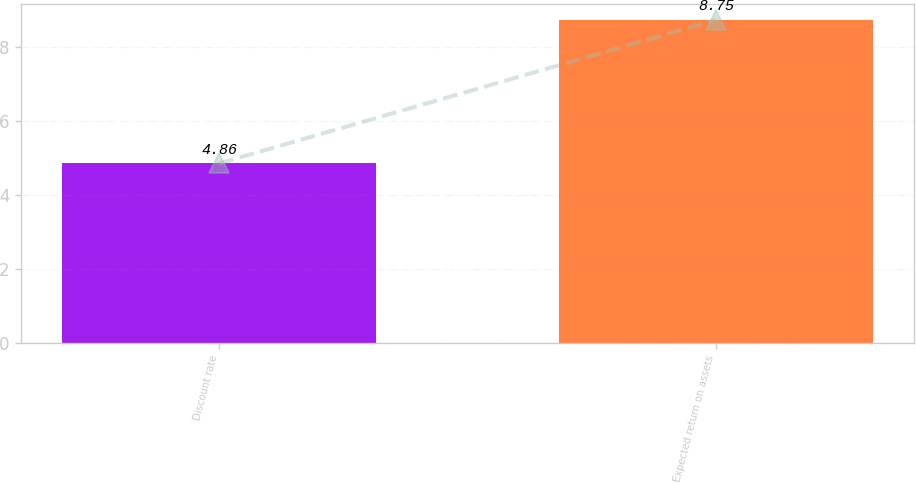Convert chart. <chart><loc_0><loc_0><loc_500><loc_500><bar_chart><fcel>Discount rate<fcel>Expected return on assets<nl><fcel>4.86<fcel>8.75<nl></chart> 